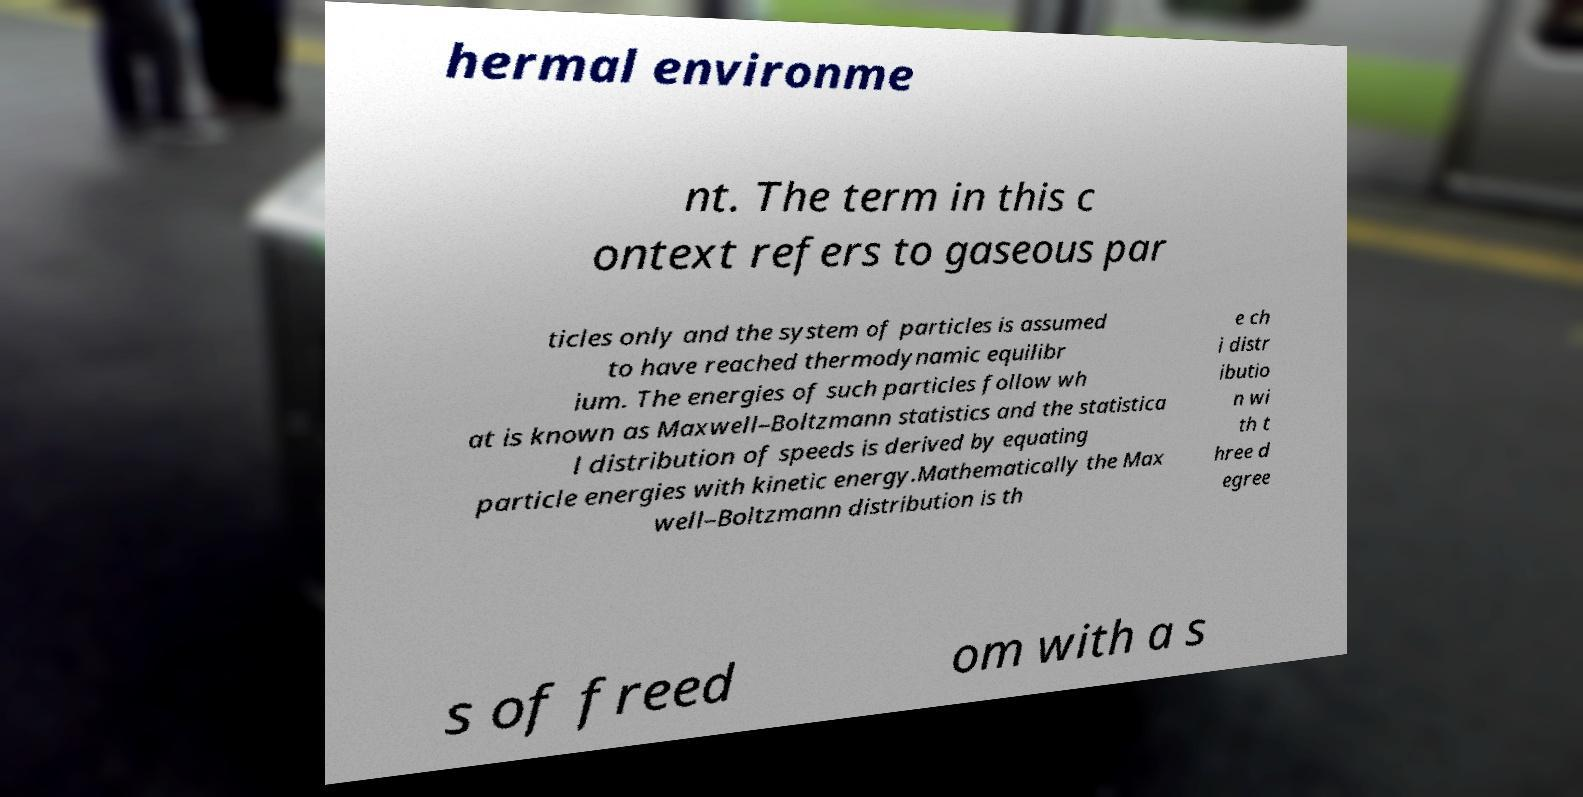I need the written content from this picture converted into text. Can you do that? hermal environme nt. The term in this c ontext refers to gaseous par ticles only and the system of particles is assumed to have reached thermodynamic equilibr ium. The energies of such particles follow wh at is known as Maxwell–Boltzmann statistics and the statistica l distribution of speeds is derived by equating particle energies with kinetic energy.Mathematically the Max well–Boltzmann distribution is th e ch i distr ibutio n wi th t hree d egree s of freed om with a s 